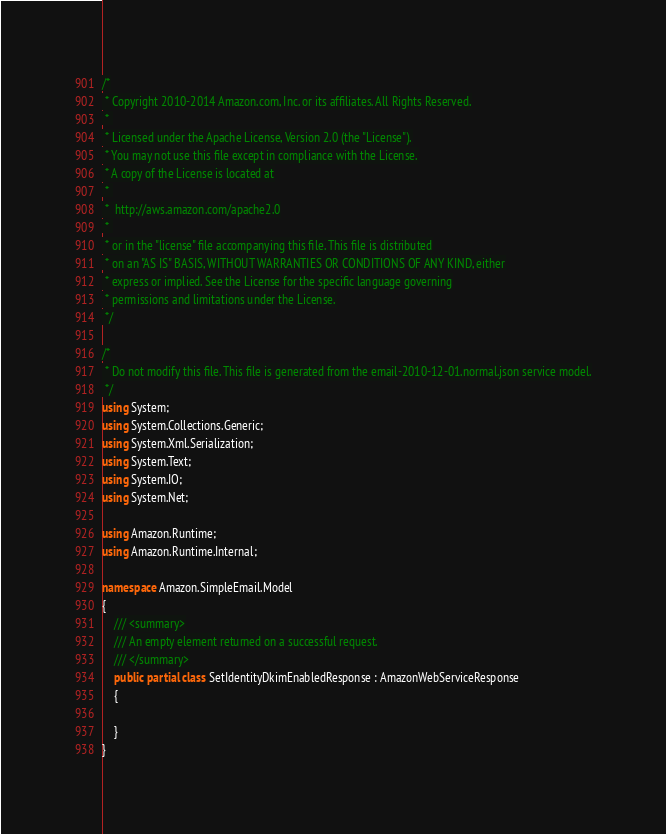Convert code to text. <code><loc_0><loc_0><loc_500><loc_500><_C#_>/*
 * Copyright 2010-2014 Amazon.com, Inc. or its affiliates. All Rights Reserved.
 * 
 * Licensed under the Apache License, Version 2.0 (the "License").
 * You may not use this file except in compliance with the License.
 * A copy of the License is located at
 * 
 *  http://aws.amazon.com/apache2.0
 * 
 * or in the "license" file accompanying this file. This file is distributed
 * on an "AS IS" BASIS, WITHOUT WARRANTIES OR CONDITIONS OF ANY KIND, either
 * express or implied. See the License for the specific language governing
 * permissions and limitations under the License.
 */

/*
 * Do not modify this file. This file is generated from the email-2010-12-01.normal.json service model.
 */
using System;
using System.Collections.Generic;
using System.Xml.Serialization;
using System.Text;
using System.IO;
using System.Net;

using Amazon.Runtime;
using Amazon.Runtime.Internal;

namespace Amazon.SimpleEmail.Model
{
    /// <summary>
    /// An empty element returned on a successful request.
    /// </summary>
    public partial class SetIdentityDkimEnabledResponse : AmazonWebServiceResponse
    {

    }
}</code> 